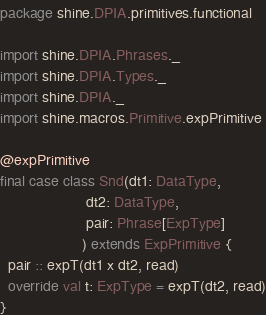Convert code to text. <code><loc_0><loc_0><loc_500><loc_500><_Scala_>package shine.DPIA.primitives.functional

import shine.DPIA.Phrases._
import shine.DPIA.Types._
import shine.DPIA._
import shine.macros.Primitive.expPrimitive

@expPrimitive
final case class Snd(dt1: DataType,
                     dt2: DataType,
                     pair: Phrase[ExpType]
                    ) extends ExpPrimitive {
  pair :: expT(dt1 x dt2, read)
  override val t: ExpType = expT(dt2, read)
}
</code> 